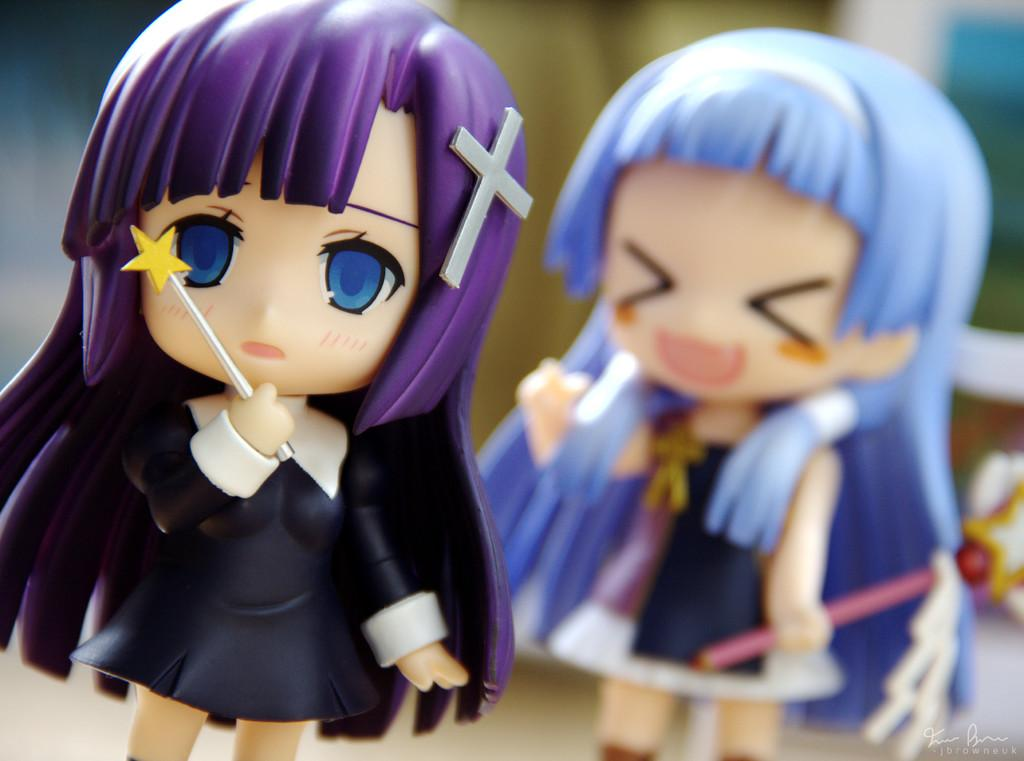How many dolls are present in the image? There are two dolls in the image. Can you describe the background of the image? The background of the image is blurred. What letter is being carried by the zephyr in the image? There is no zephyr or letter present in the image. What type of vessel is visible in the image? There is no vessel present in the image. 